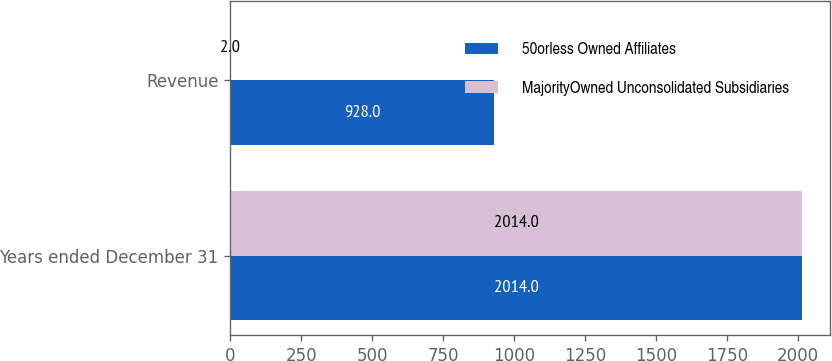<chart> <loc_0><loc_0><loc_500><loc_500><stacked_bar_chart><ecel><fcel>Years ended December 31<fcel>Revenue<nl><fcel>50orless Owned Affiliates<fcel>2014<fcel>928<nl><fcel>MajorityOwned Unconsolidated Subsidiaries<fcel>2014<fcel>2<nl></chart> 